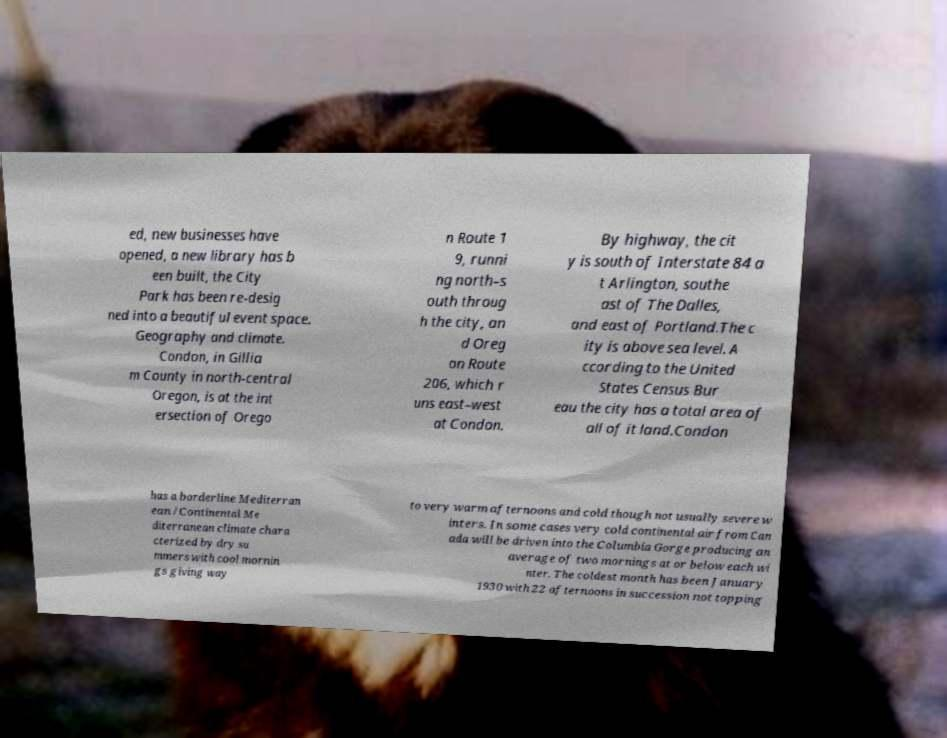What messages or text are displayed in this image? I need them in a readable, typed format. ed, new businesses have opened, a new library has b een built, the City Park has been re-desig ned into a beautiful event space. Geography and climate. Condon, in Gillia m County in north-central Oregon, is at the int ersection of Orego n Route 1 9, runni ng north–s outh throug h the city, an d Oreg on Route 206, which r uns east–west at Condon. By highway, the cit y is south of Interstate 84 a t Arlington, southe ast of The Dalles, and east of Portland.The c ity is above sea level. A ccording to the United States Census Bur eau the city has a total area of all of it land.Condon has a borderline Mediterran ean /Continental Me diterranean climate chara cterized by dry su mmers with cool mornin gs giving way to very warm afternoons and cold though not usually severe w inters. In some cases very cold continental air from Can ada will be driven into the Columbia Gorge producing an average of two mornings at or below each wi nter. The coldest month has been January 1930 with 22 afternoons in succession not topping 